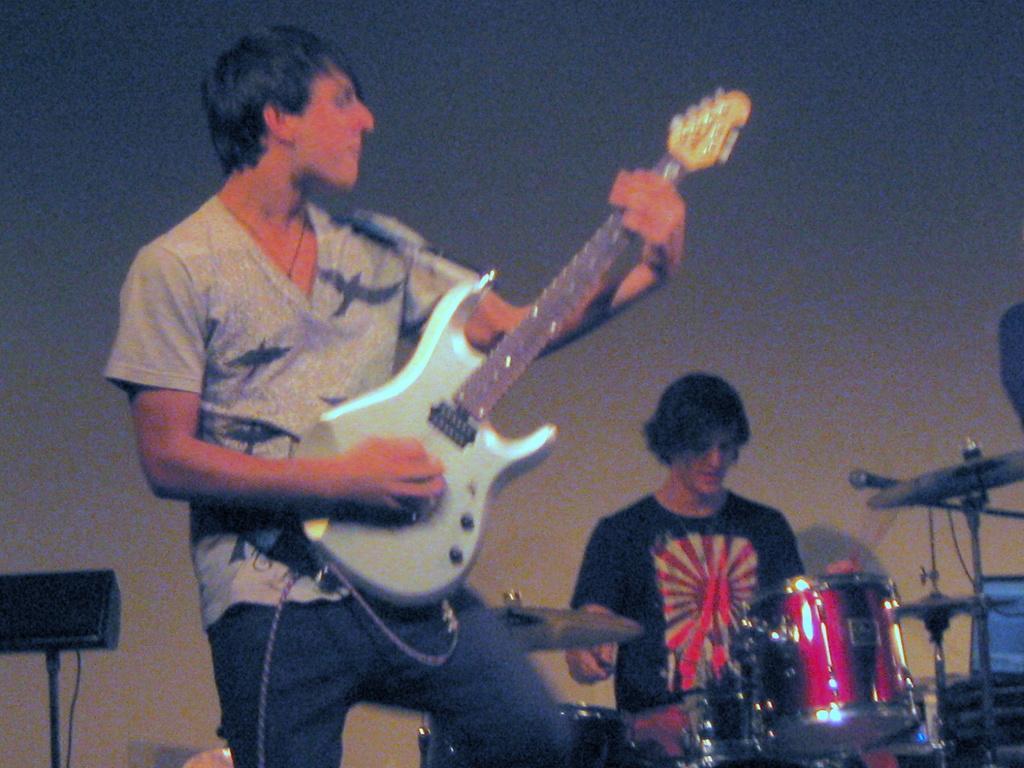Could you give a brief overview of what you see in this image? There is a man standing and playing guitar. In the background there is a man sitting and playing musical instrument and wall. 